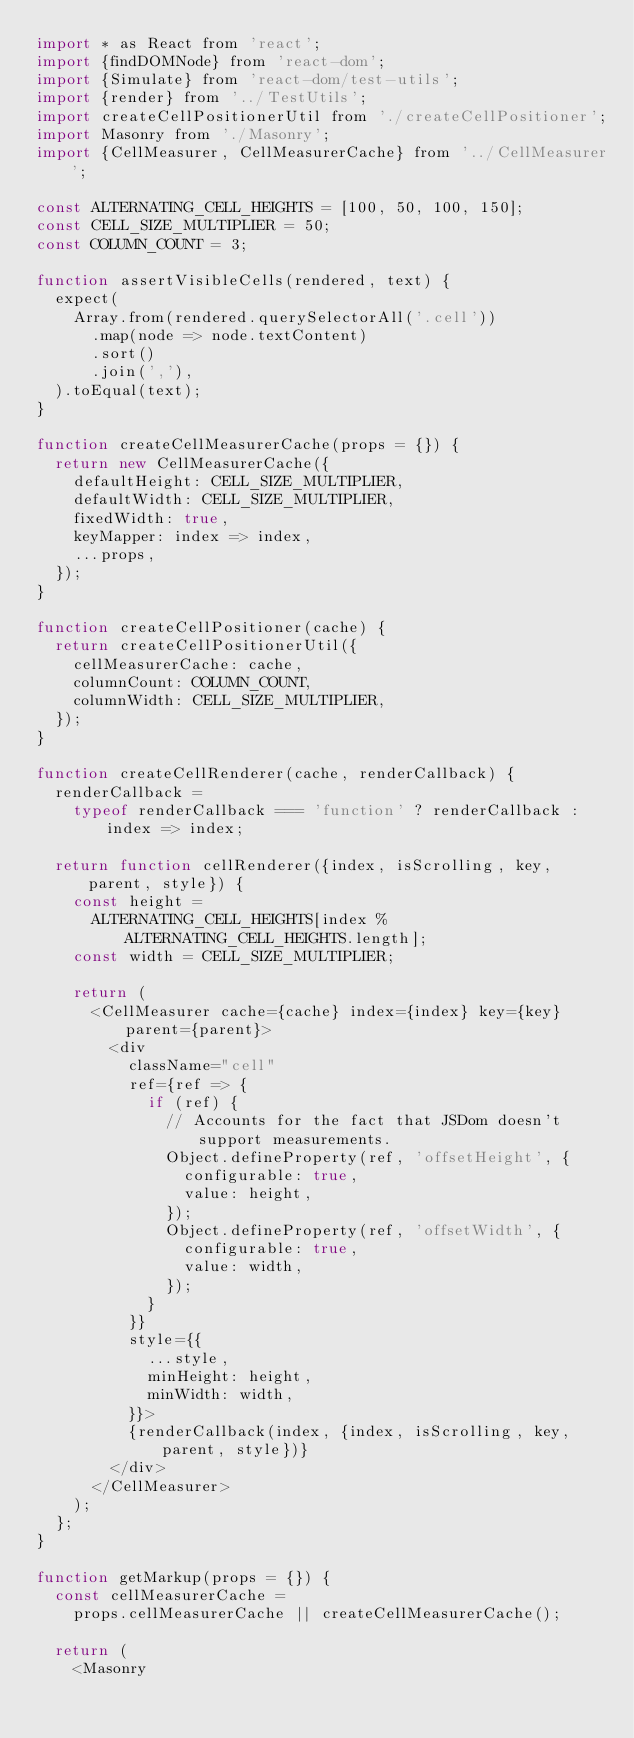Convert code to text. <code><loc_0><loc_0><loc_500><loc_500><_JavaScript_>import * as React from 'react';
import {findDOMNode} from 'react-dom';
import {Simulate} from 'react-dom/test-utils';
import {render} from '../TestUtils';
import createCellPositionerUtil from './createCellPositioner';
import Masonry from './Masonry';
import {CellMeasurer, CellMeasurerCache} from '../CellMeasurer';

const ALTERNATING_CELL_HEIGHTS = [100, 50, 100, 150];
const CELL_SIZE_MULTIPLIER = 50;
const COLUMN_COUNT = 3;

function assertVisibleCells(rendered, text) {
  expect(
    Array.from(rendered.querySelectorAll('.cell'))
      .map(node => node.textContent)
      .sort()
      .join(','),
  ).toEqual(text);
}

function createCellMeasurerCache(props = {}) {
  return new CellMeasurerCache({
    defaultHeight: CELL_SIZE_MULTIPLIER,
    defaultWidth: CELL_SIZE_MULTIPLIER,
    fixedWidth: true,
    keyMapper: index => index,
    ...props,
  });
}

function createCellPositioner(cache) {
  return createCellPositionerUtil({
    cellMeasurerCache: cache,
    columnCount: COLUMN_COUNT,
    columnWidth: CELL_SIZE_MULTIPLIER,
  });
}

function createCellRenderer(cache, renderCallback) {
  renderCallback =
    typeof renderCallback === 'function' ? renderCallback : index => index;

  return function cellRenderer({index, isScrolling, key, parent, style}) {
    const height =
      ALTERNATING_CELL_HEIGHTS[index % ALTERNATING_CELL_HEIGHTS.length];
    const width = CELL_SIZE_MULTIPLIER;

    return (
      <CellMeasurer cache={cache} index={index} key={key} parent={parent}>
        <div
          className="cell"
          ref={ref => {
            if (ref) {
              // Accounts for the fact that JSDom doesn't support measurements.
              Object.defineProperty(ref, 'offsetHeight', {
                configurable: true,
                value: height,
              });
              Object.defineProperty(ref, 'offsetWidth', {
                configurable: true,
                value: width,
              });
            }
          }}
          style={{
            ...style,
            minHeight: height,
            minWidth: width,
          }}>
          {renderCallback(index, {index, isScrolling, key, parent, style})}
        </div>
      </CellMeasurer>
    );
  };
}

function getMarkup(props = {}) {
  const cellMeasurerCache =
    props.cellMeasurerCache || createCellMeasurerCache();

  return (
    <Masonry</code> 